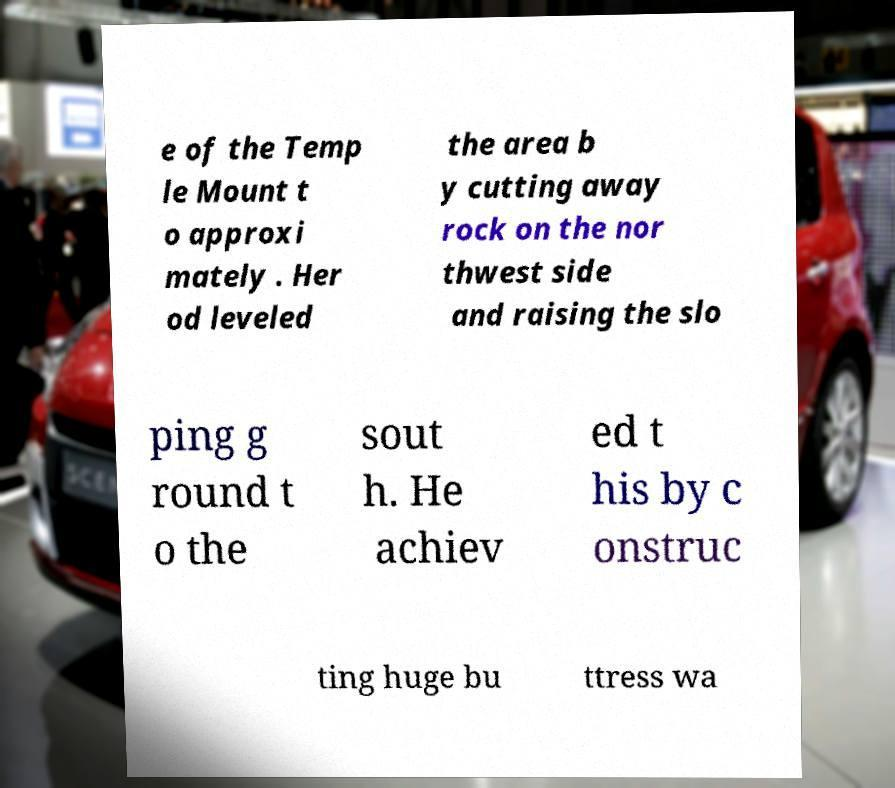Can you read and provide the text displayed in the image?This photo seems to have some interesting text. Can you extract and type it out for me? e of the Temp le Mount t o approxi mately . Her od leveled the area b y cutting away rock on the nor thwest side and raising the slo ping g round t o the sout h. He achiev ed t his by c onstruc ting huge bu ttress wa 